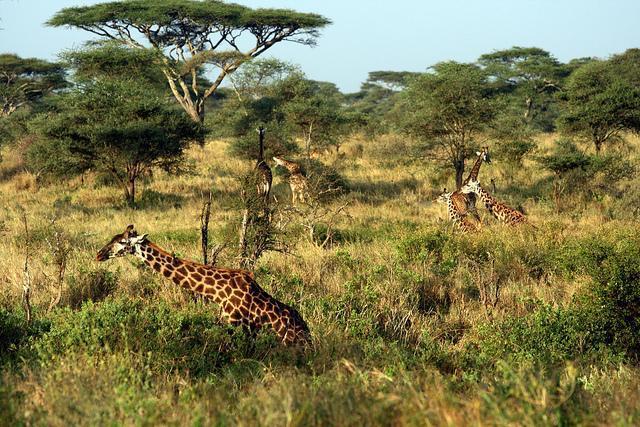How many people are wearing a red helmet?
Give a very brief answer. 0. 